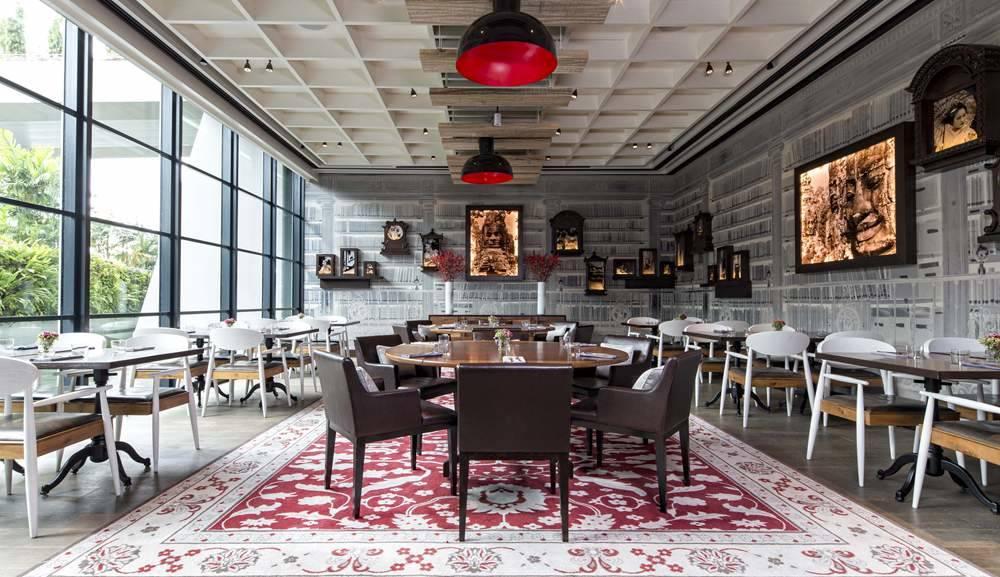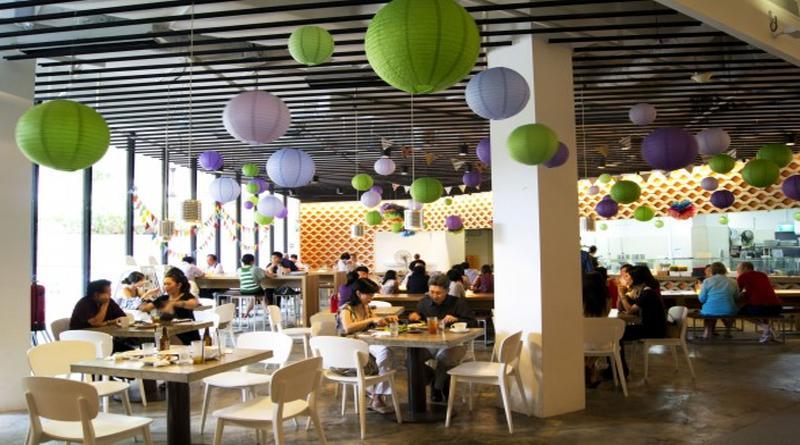The first image is the image on the left, the second image is the image on the right. For the images displayed, is the sentence "In one image, green things are suspended from the ceiling over a dining area that includes square tables for four." factually correct? Answer yes or no. Yes. The first image is the image on the left, the second image is the image on the right. Analyze the images presented: Is the assertion "Some tables have glass candle holders on them." valid? Answer yes or no. No. 